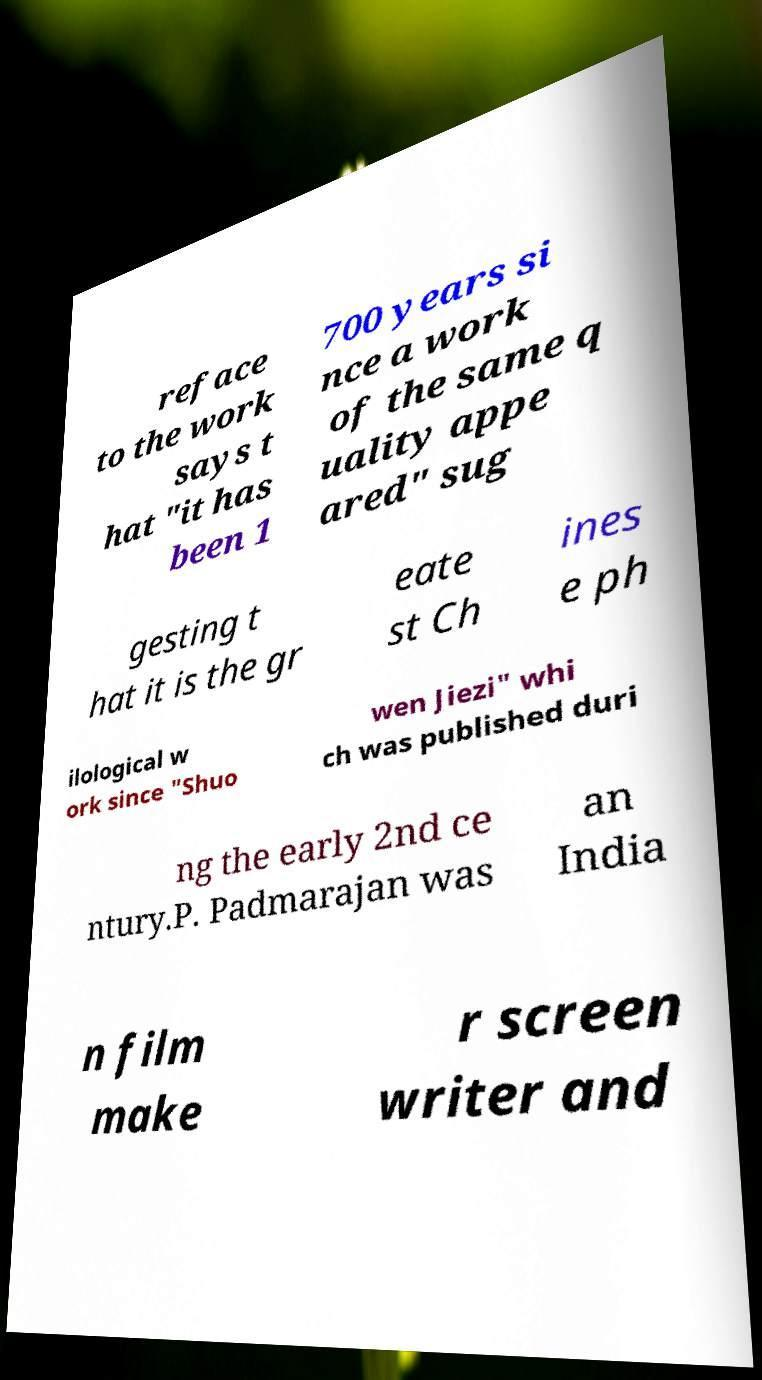Could you extract and type out the text from this image? reface to the work says t hat "it has been 1 700 years si nce a work of the same q uality appe ared" sug gesting t hat it is the gr eate st Ch ines e ph ilological w ork since "Shuo wen Jiezi" whi ch was published duri ng the early 2nd ce ntury.P. Padmarajan was an India n film make r screen writer and 